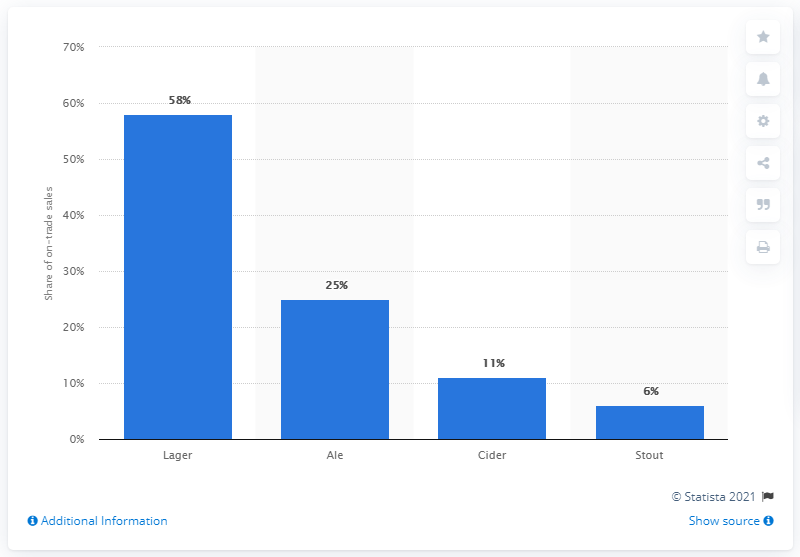Highlight a few significant elements in this photo. In 2012, lager was the category of beer that held the largest share of on-trade beer sales in the UK. 